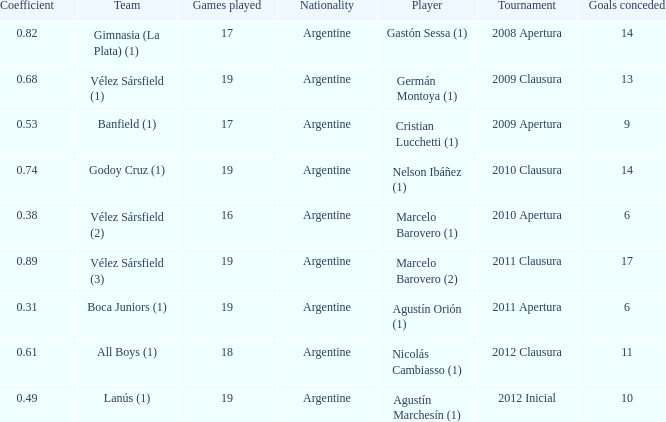What is the nationality of the 2012 clausura  tournament? Argentine. 